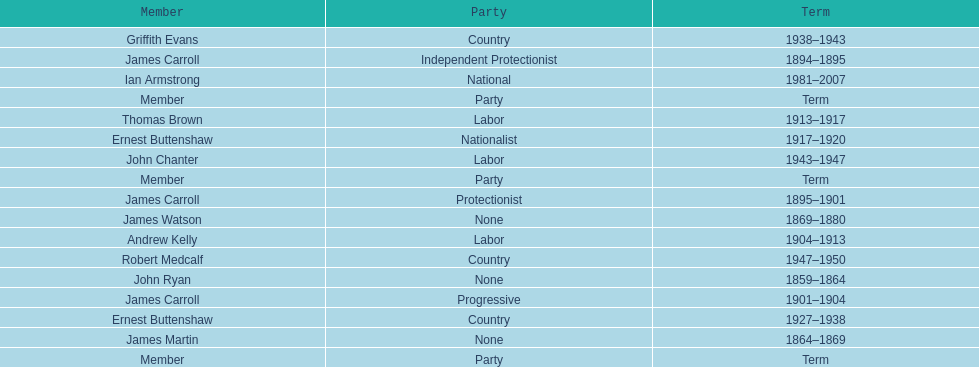Of the members of the third incarnation of the lachlan, who served the longest? Ernest Buttenshaw. 